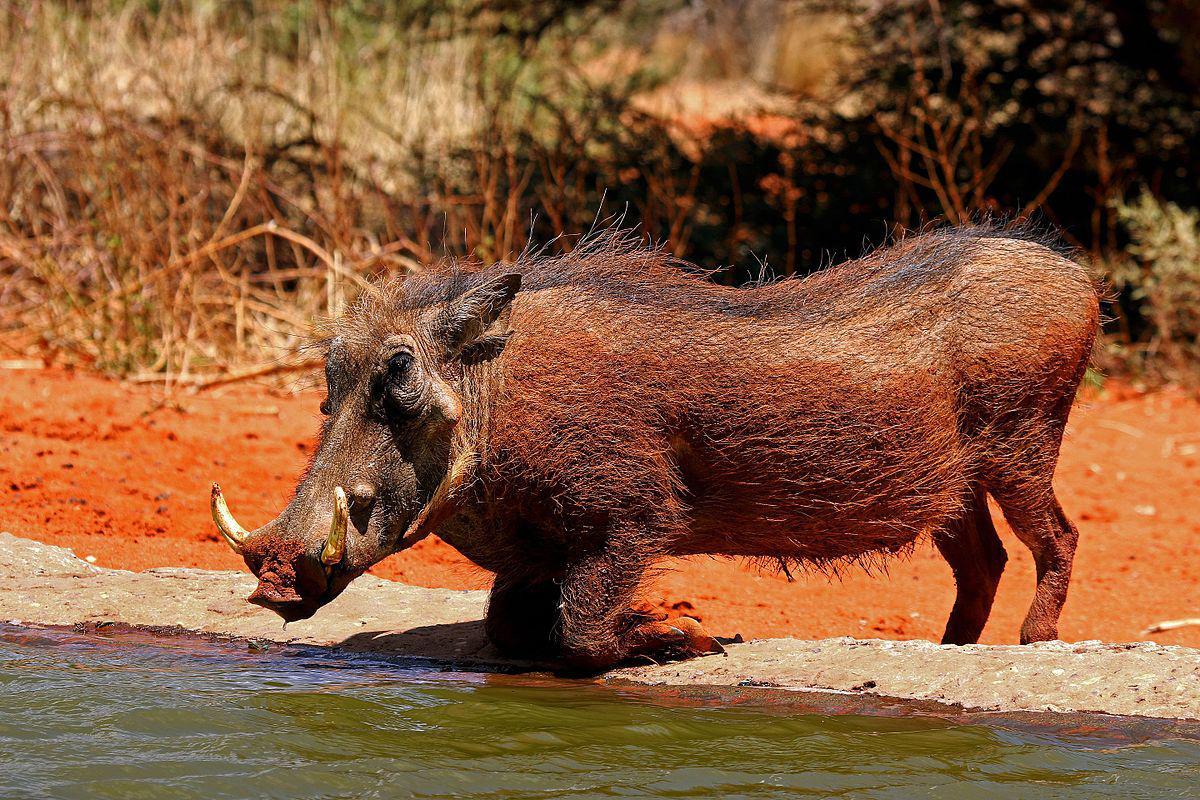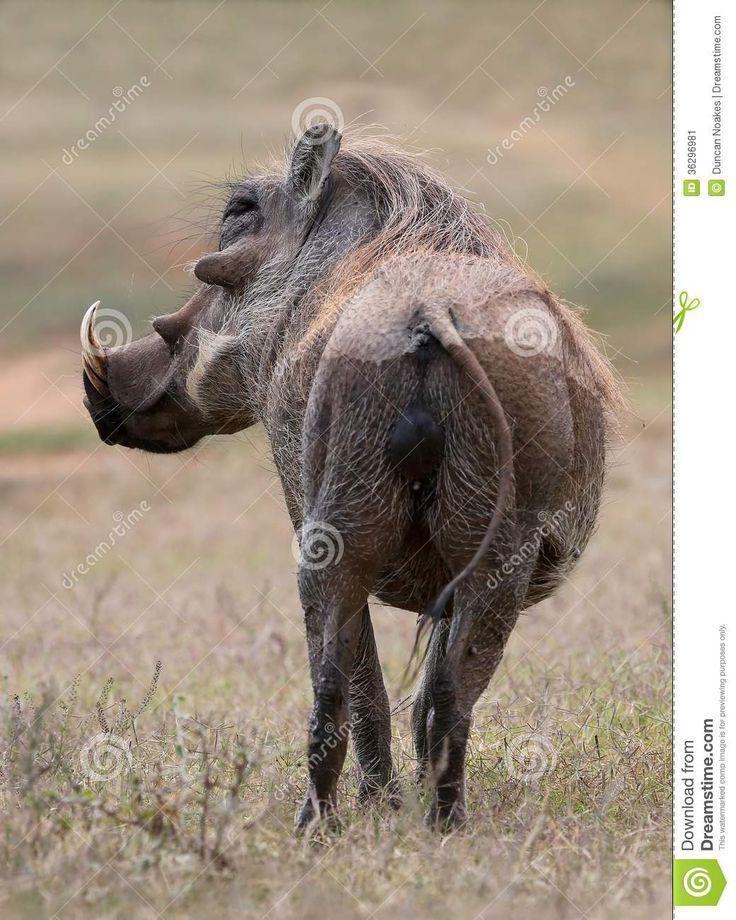The first image is the image on the left, the second image is the image on the right. For the images displayed, is the sentence "The only animals shown are exactly two warthogs, in total." factually correct? Answer yes or no. Yes. 